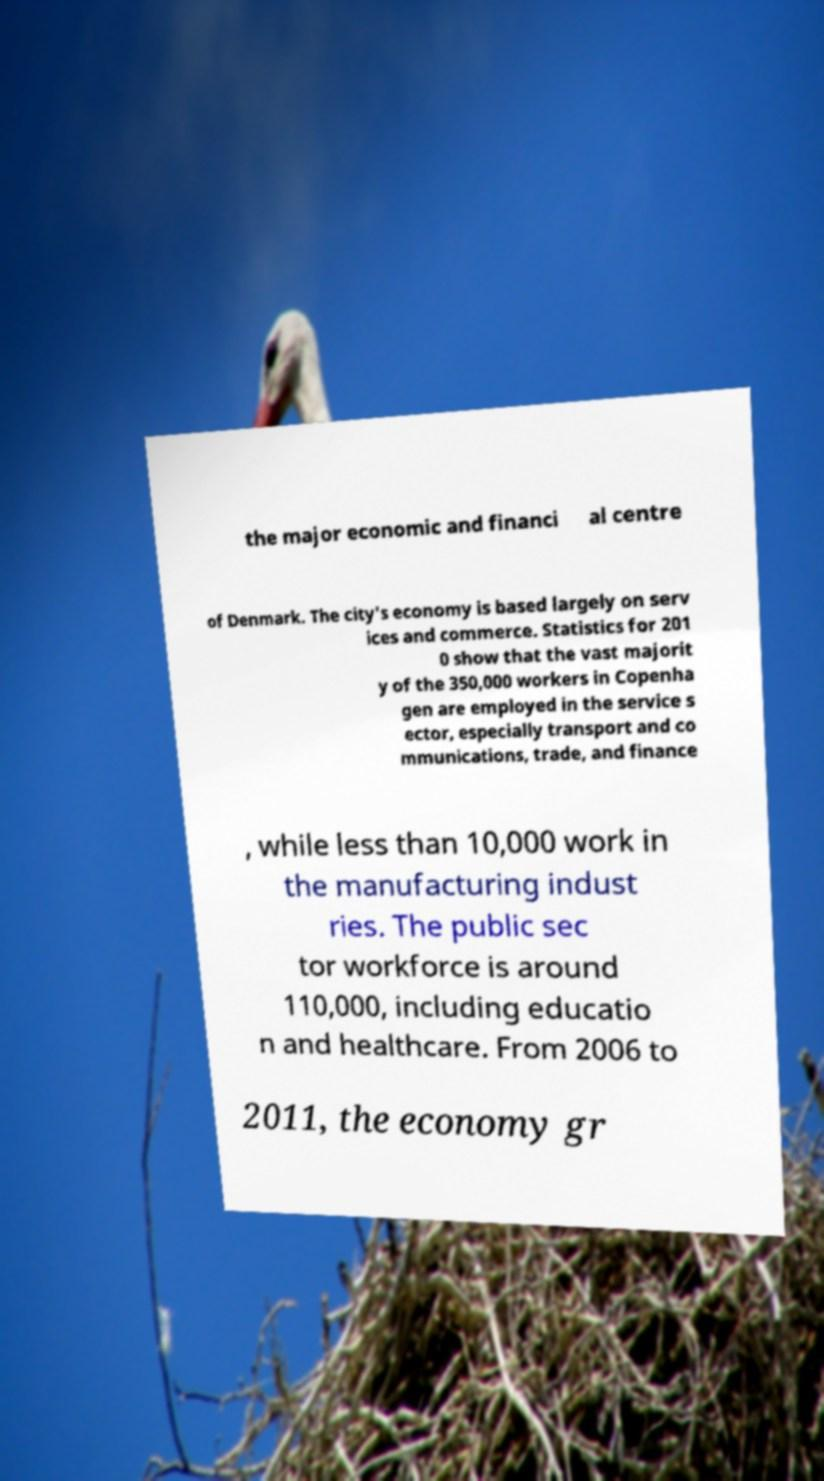Could you extract and type out the text from this image? the major economic and financi al centre of Denmark. The city's economy is based largely on serv ices and commerce. Statistics for 201 0 show that the vast majorit y of the 350,000 workers in Copenha gen are employed in the service s ector, especially transport and co mmunications, trade, and finance , while less than 10,000 work in the manufacturing indust ries. The public sec tor workforce is around 110,000, including educatio n and healthcare. From 2006 to 2011, the economy gr 